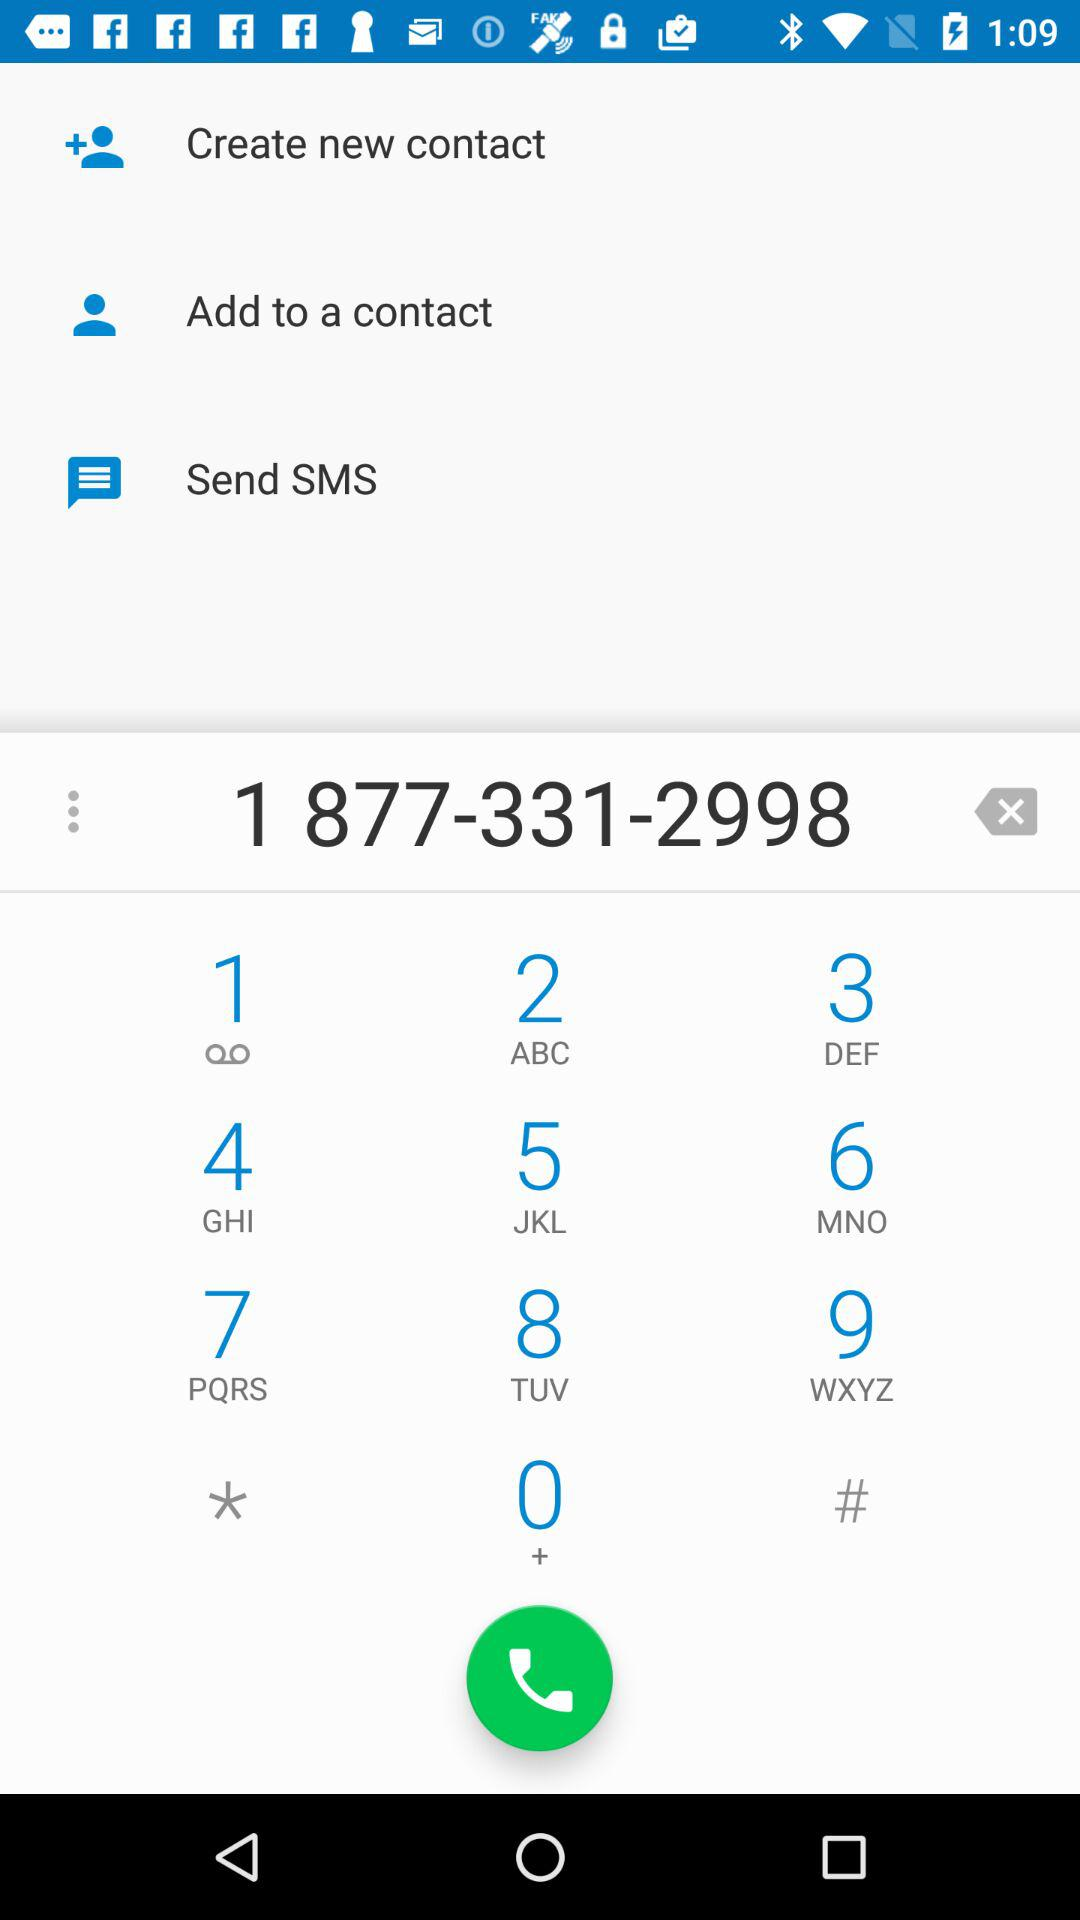What are the options that I can use for the phone number 1 877-331-2998? The options that you can use are "Create new contact", "Add to a contact", "Send SMS" and "Call". 